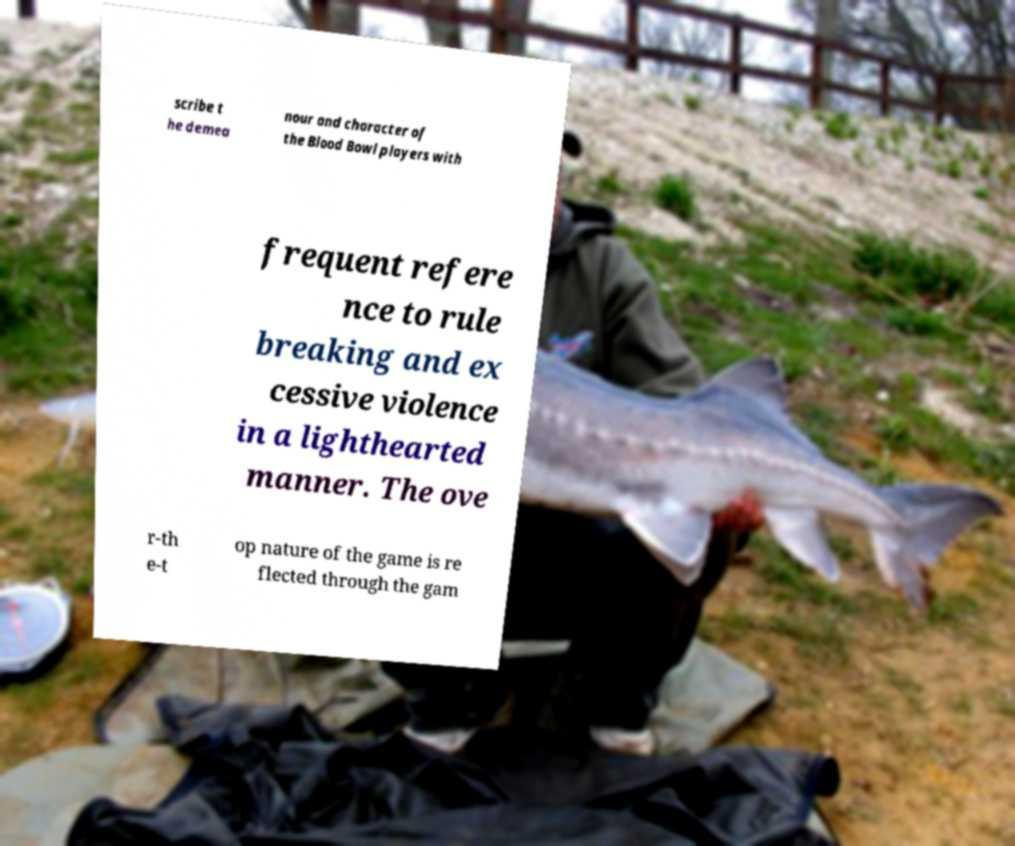Can you accurately transcribe the text from the provided image for me? scribe t he demea nour and character of the Blood Bowl players with frequent refere nce to rule breaking and ex cessive violence in a lighthearted manner. The ove r-th e-t op nature of the game is re flected through the gam 